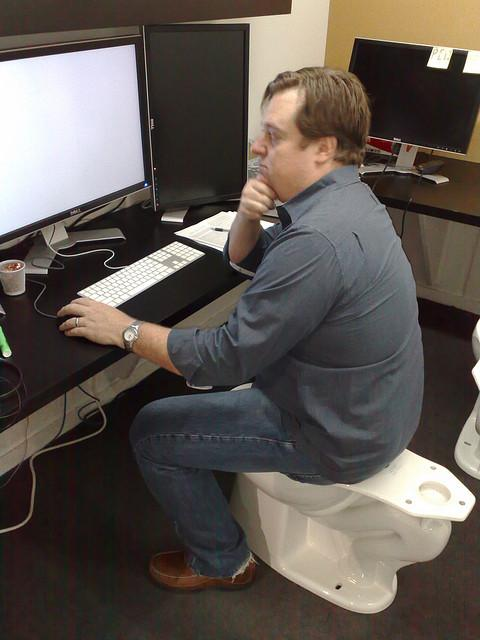What part of this mans furniture is most surprising? Please explain your reasoning. toilet. The man seems to be  be sitting on the toilet. 